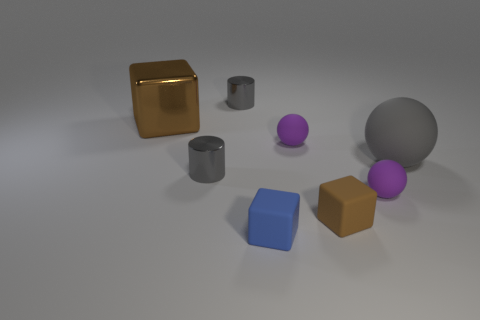Add 2 rubber spheres. How many objects exist? 10 Subtract all balls. How many objects are left? 5 Subtract 1 gray cylinders. How many objects are left? 7 Subtract all brown metallic things. Subtract all tiny rubber blocks. How many objects are left? 5 Add 6 tiny blue things. How many tiny blue things are left? 7 Add 2 rubber objects. How many rubber objects exist? 7 